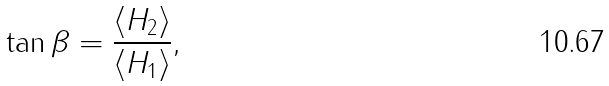Convert formula to latex. <formula><loc_0><loc_0><loc_500><loc_500>\tan \beta = \frac { \langle H _ { 2 } \rangle } { \langle H _ { 1 } \rangle } ,</formula> 